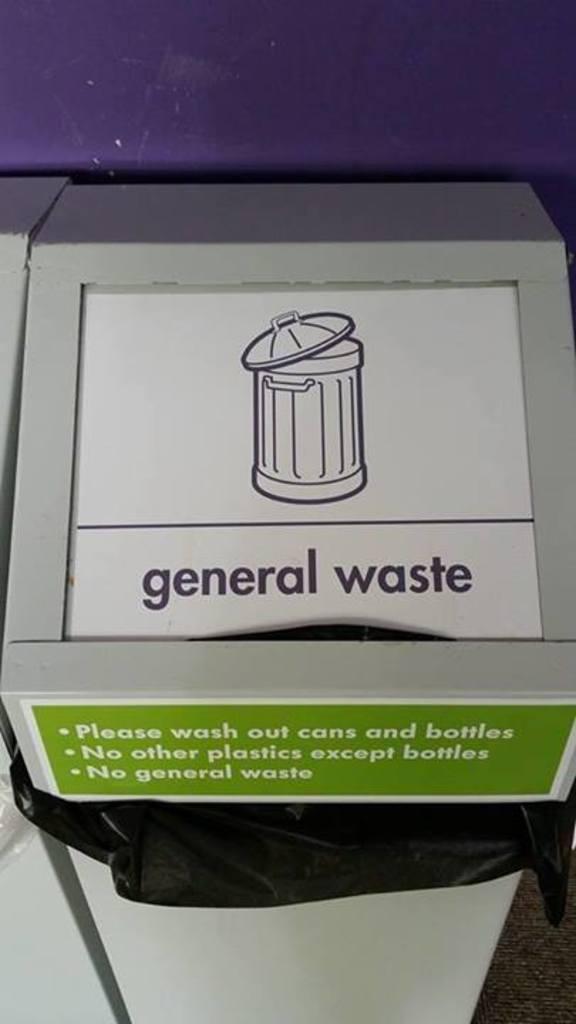Please provide a concise description of this image. In this image in the center there is one dustbin, and in the background there is a wall. 